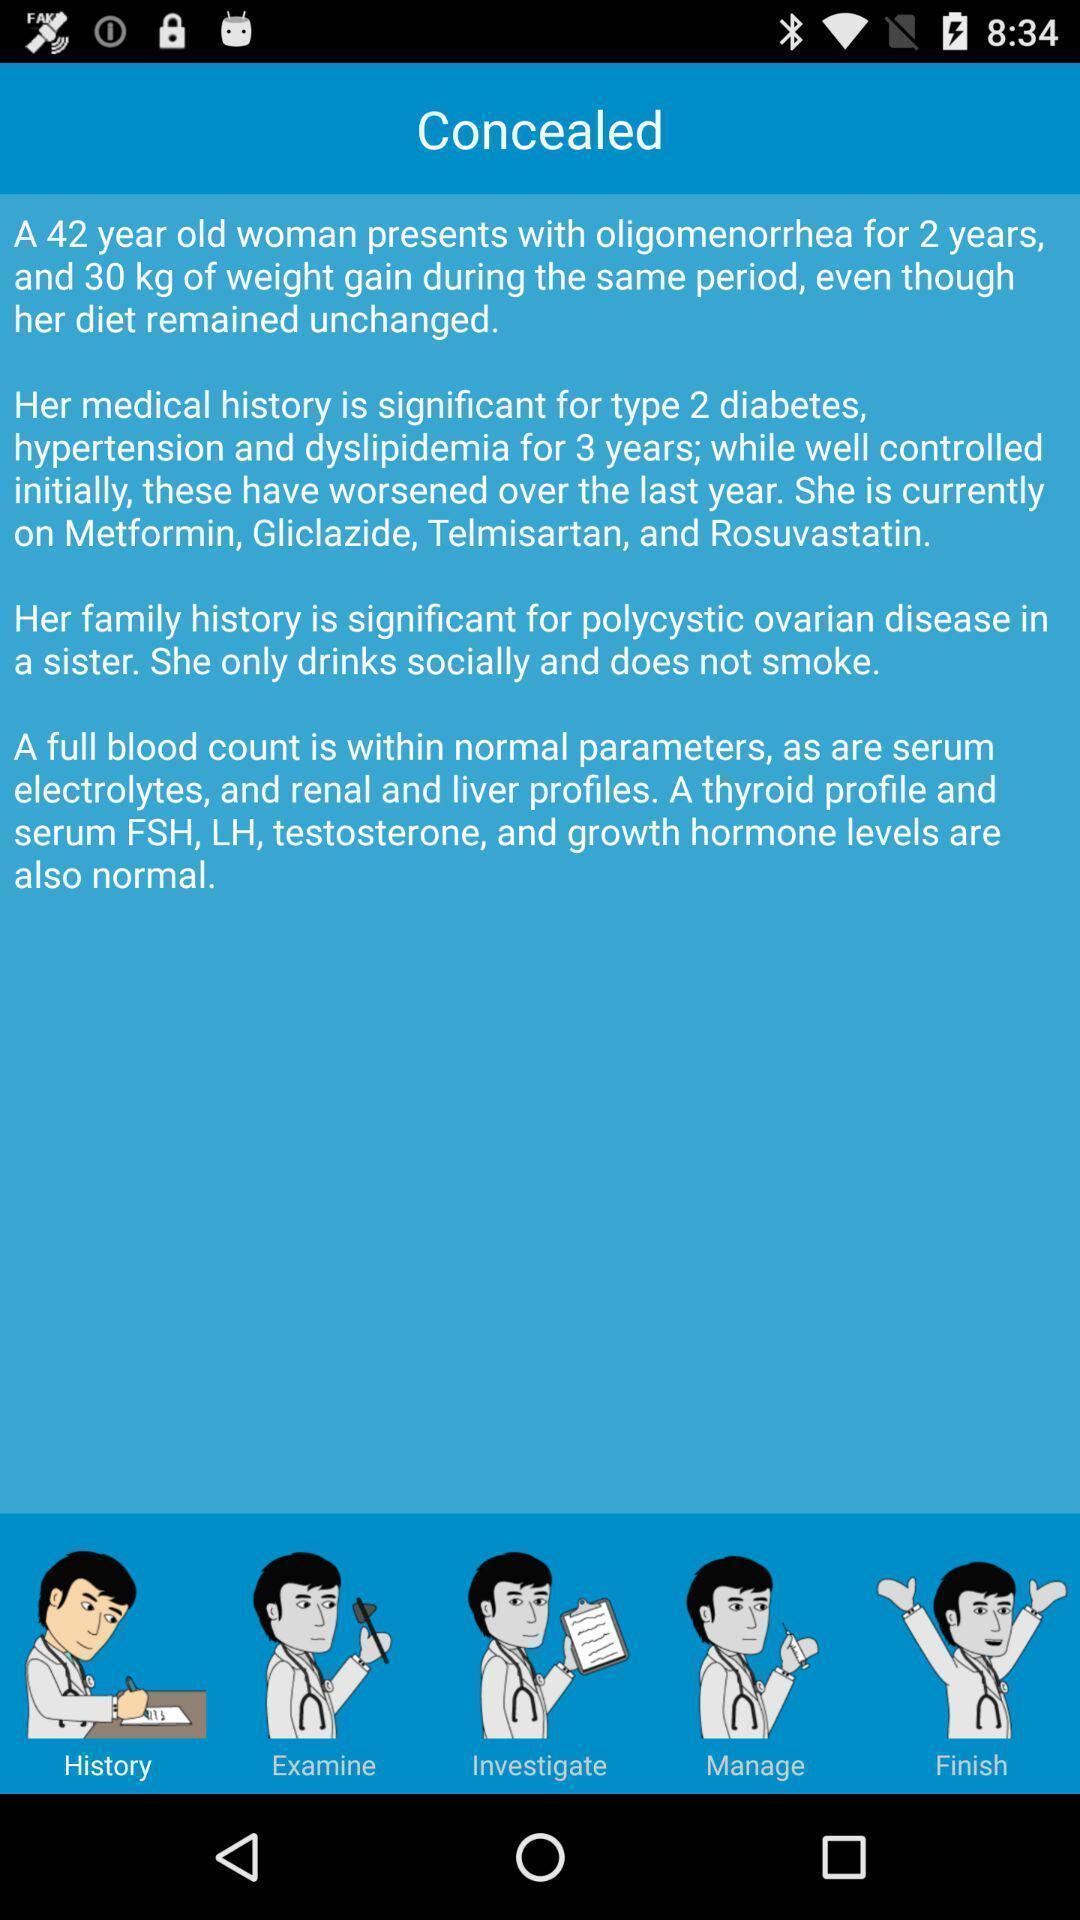Describe the content in this image. Story about a person 's health details in a healthcare app. 